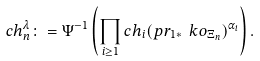Convert formula to latex. <formula><loc_0><loc_0><loc_500><loc_500>c h _ { n } ^ { \lambda } \colon = \Psi ^ { - 1 } \left ( \prod _ { i \geq 1 } c h _ { i } ( p r _ { 1 * } \ k o _ { \Xi _ { n } } ) ^ { \alpha _ { i } } \right ) .</formula> 